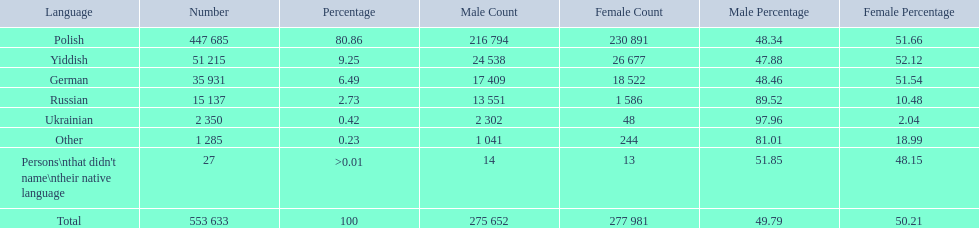What language makes a majority Polish. What the the total number of speakers? 553 633. 